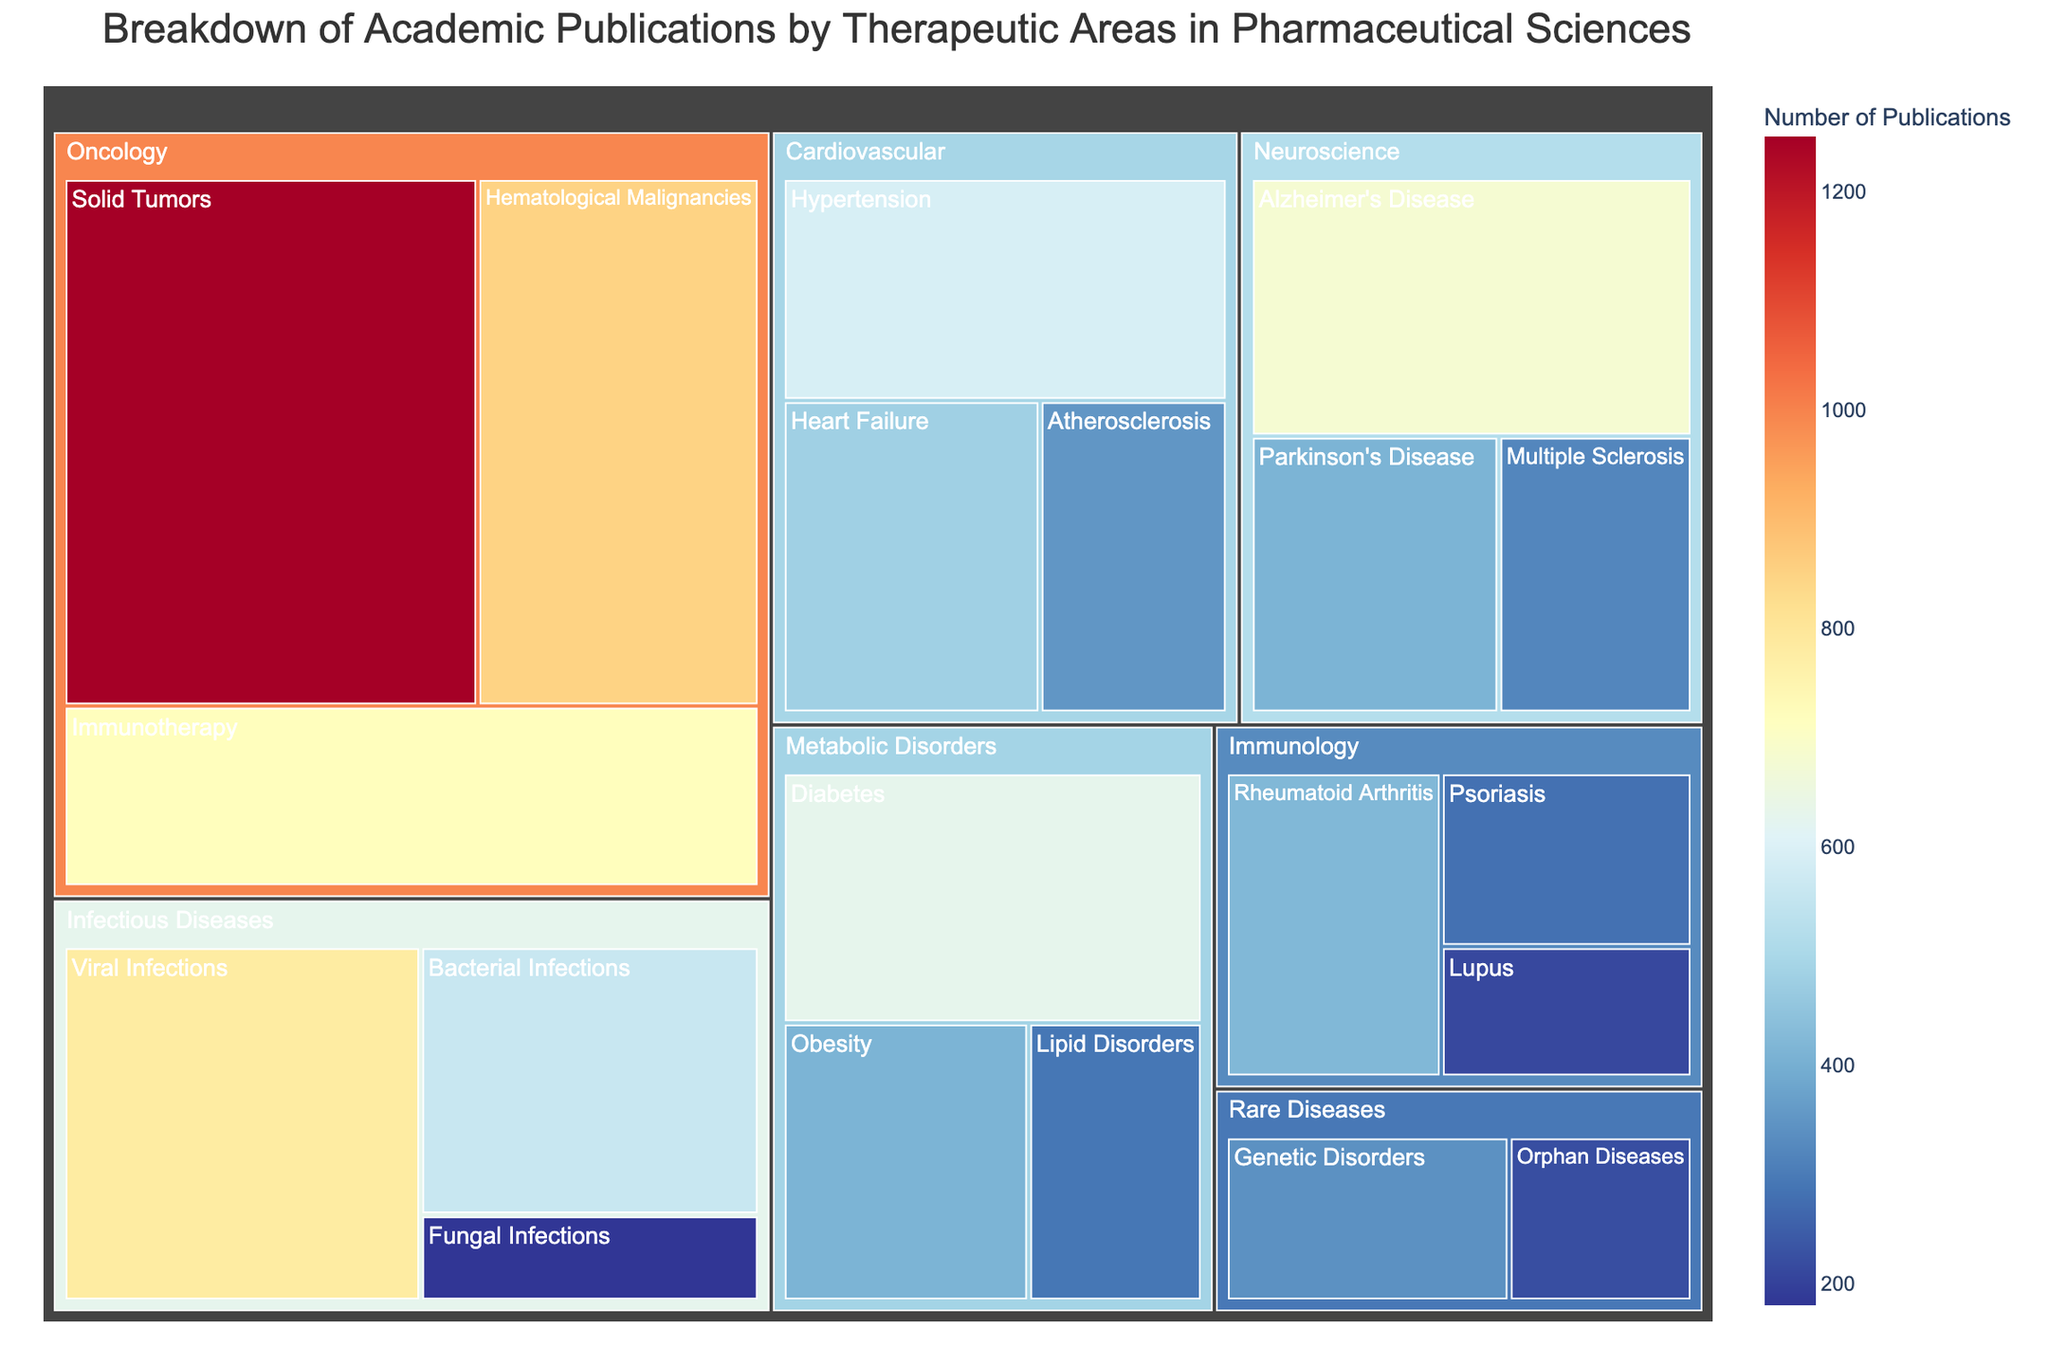What is the title of the treemap? The title is usually displayed prominently at the top of the visualization. By checking the top of the treemap, we can find that the title is 'Breakdown of Academic Publications by Therapeutic Areas in Pharmaceutical Sciences'.
Answer: Breakdown of Academic Publications by Therapeutic Areas in Pharmaceutical Sciences What therapeutic area has the highest number of publications? By looking at the treemap, the largest segment represents the area with the highest number of publications. In this case, Oncology has the largest sections indicating it has the highest number.
Answer: Oncology How many publications are there in Immunotherapy under Oncology? Hovering over the Immunotherapy section in Oncology, the hover data displays the exact number of publications, which is 720.
Answer: 720 Summing up the number of publications in Neuroscience, what is the total? Add the publications in Alzheimer's Disease, Parkinson's Disease, and Multiple Sclerosis. 680 + 410 + 320 gives a total of 1410 publications.
Answer: 1410 Compare the number of publications between Hypertension and Diabetes. Which one has more? Check the size of the segments and hover to see the numbers. Hypertension has 590 publications whereas Diabetes has 630, so Diabetes has more.
Answer: Diabetes Which therapeutic sub-area in Infectious Diseases has the least number of publications? By examining each sub-area within Infectious Diseases and looking for the smallest segment, we see that Fungal Infections has the least with 180 publications.
Answer: Fungal Infections What therapeutic area has the fewest total publications? Compare the total publications across all therapeutic areas by summing the sub-areas within each. Rare Diseases have the fewest, with Genetic Disorders and Orphan Diseases totaling to 560 publications.
Answer: Rare Diseases Within Cardiovascular therapeutic areas, how much more is the number of publications in Heart Failure than in Atherosclerosis? By hovering over the respective sections, we find that Heart Failure has 480 publications and Atherosclerosis has 350. The difference is 480 - 350, which is 130.
Answer: 130 What percentage of publications in Metabolic Disorders is about Diabetes? To find this, divide the number of Diabetes publications by the total for Metabolic Disorders, then multiply by 100. 630 / (630 + 410 + 290) = 630 / 1330 ≈ 0.4737 => 47.37%.
Answer: 47.37% 